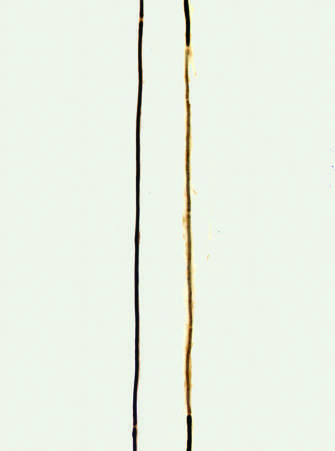how is a normal axon with a long thick dark myelin internode flanked?
Answer the question using a single word or phrase. By nodes of ranvier 